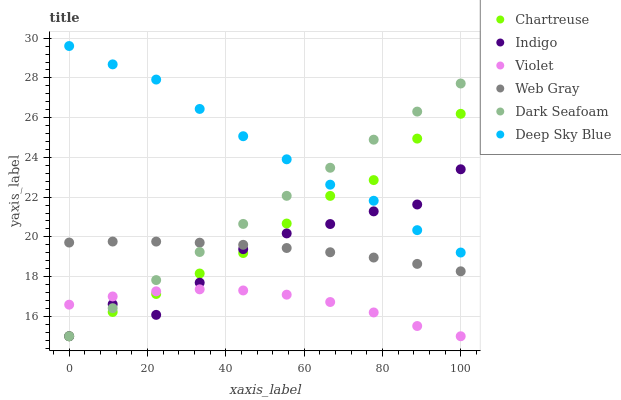Does Violet have the minimum area under the curve?
Answer yes or no. Yes. Does Deep Sky Blue have the maximum area under the curve?
Answer yes or no. Yes. Does Indigo have the minimum area under the curve?
Answer yes or no. No. Does Indigo have the maximum area under the curve?
Answer yes or no. No. Is Dark Seafoam the smoothest?
Answer yes or no. Yes. Is Indigo the roughest?
Answer yes or no. Yes. Is Indigo the smoothest?
Answer yes or no. No. Is Dark Seafoam the roughest?
Answer yes or no. No. Does Indigo have the lowest value?
Answer yes or no. Yes. Does Deep Sky Blue have the lowest value?
Answer yes or no. No. Does Deep Sky Blue have the highest value?
Answer yes or no. Yes. Does Indigo have the highest value?
Answer yes or no. No. Is Violet less than Deep Sky Blue?
Answer yes or no. Yes. Is Deep Sky Blue greater than Web Gray?
Answer yes or no. Yes. Does Indigo intersect Chartreuse?
Answer yes or no. Yes. Is Indigo less than Chartreuse?
Answer yes or no. No. Is Indigo greater than Chartreuse?
Answer yes or no. No. Does Violet intersect Deep Sky Blue?
Answer yes or no. No. 